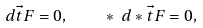<formula> <loc_0><loc_0><loc_500><loc_500>d \vec { t } { F } = 0 , \quad * \ d * \vec { t } { F } = 0 ,</formula> 